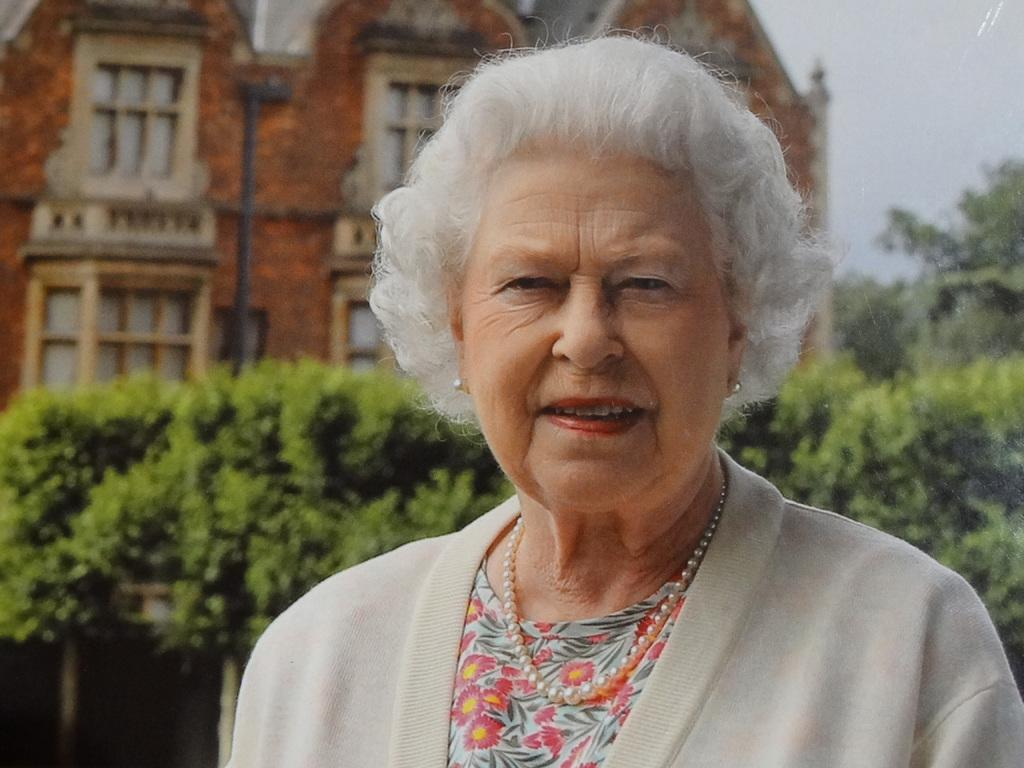Who is present in the image? There is a woman in the image. What is the woman's expression? The woman is smiling. What can be seen in the background of the image? There are plants, trees, a building, a pole, and the sky visible in the background of the image. What type of record is the woman holding in the image? There is no record present in the image; the woman is not holding anything. 